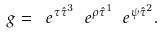Convert formula to latex. <formula><loc_0><loc_0><loc_500><loc_500>g = \ e ^ { \tau \hat { \tau } ^ { 3 } } \ e ^ { \rho \hat { \tau } ^ { 1 } } \ e ^ { \psi \hat { \tau } ^ { 2 } } .</formula> 